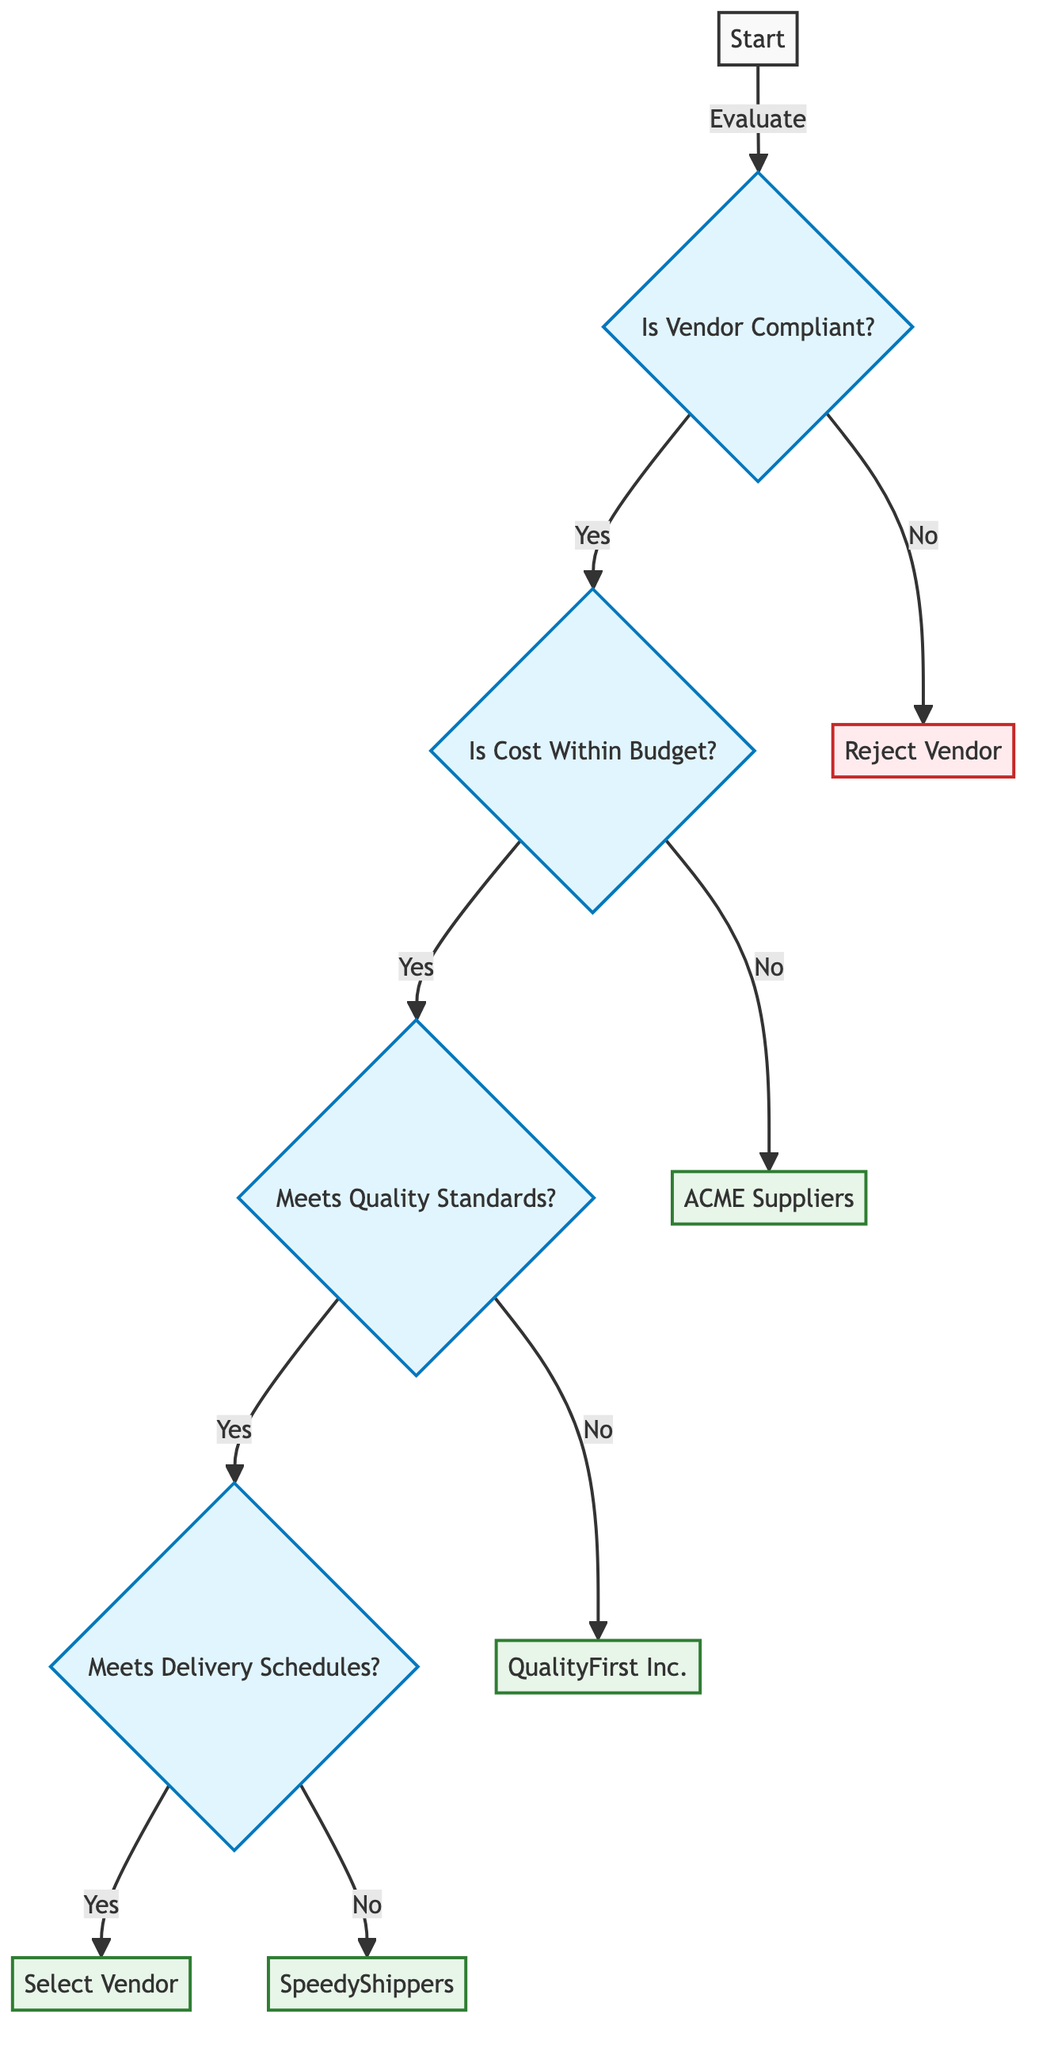What is the first question in the decision tree? The first question in the decision tree is located at the "Start" node, which asks if the vendor is compliant with regulatory requirements.
Answer: Is the Vendor Compliant with Regulatory Requirements? If the vendor is not compliant, what happens next? If the vendor is not compliant, the flow leads directly to the "Reject Vendor" outcome, indicating that the vendor is eliminated from consideration.
Answer: Reject Vendor How many main evaluations are conducted after confirming compliance? After confirming compliance, there are three main evaluations conducted: Cost, Quality, and Delivery Time, leading from one to the next based on the responses.
Answer: Three What is the outcome if the cost is not within the budget? If the cost is not within the budget, the next outcome indicated is "Cheapest Compliant Alternative: ACME Suppliers." This suggests that an alternative vendor is chosen.
Answer: Cheapest Compliant Alternative: ACME Suppliers What is the final selection if all conditions are met? If all evaluation conditions (compliance, cost within budget, quality standards, and delivery schedules) are met, the final selection made is "Select Vendor."
Answer: Select Vendor Which vendor is suggested if the quality standards are not met? If the vendor does not meet quality standards, the next suggested option is "QualityFirst Inc.," indicating it is the next best alternative for consideration.
Answer: QualityFirst Inc What happens if the vendor meets delivery schedules? If the vendor meets delivery schedules, the decision tree concludes with the outcome "Select Vendor," indicating that the vendor can be chosen for the contract.
Answer: Select Vendor Which vendor is recommended for reliable delivery if schedules are not met? If the vendor cannot meet delivery schedules, the alternative vendor recommended for reliable delivery is "SpeedyShippers." This shows that they are considered a better option for delivery reliability.
Answer: SpeedyShippers 